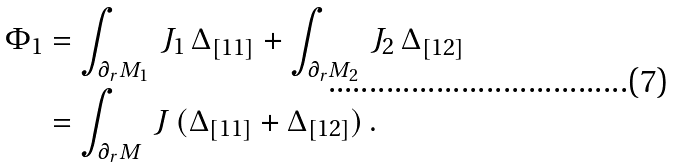Convert formula to latex. <formula><loc_0><loc_0><loc_500><loc_500>\Phi _ { 1 } & = \int _ { \partial _ { r } M _ { 1 } } \, J _ { 1 } \, \Delta _ { [ 1 1 ] } + \int _ { \partial _ { r } M _ { 2 } } \, J _ { 2 } \, \Delta _ { [ 1 2 ] } \\ & = \int _ { \partial _ { r } M } \, J \, ( \Delta _ { [ 1 1 ] } + \Delta _ { [ 1 2 ] } ) \, .</formula> 